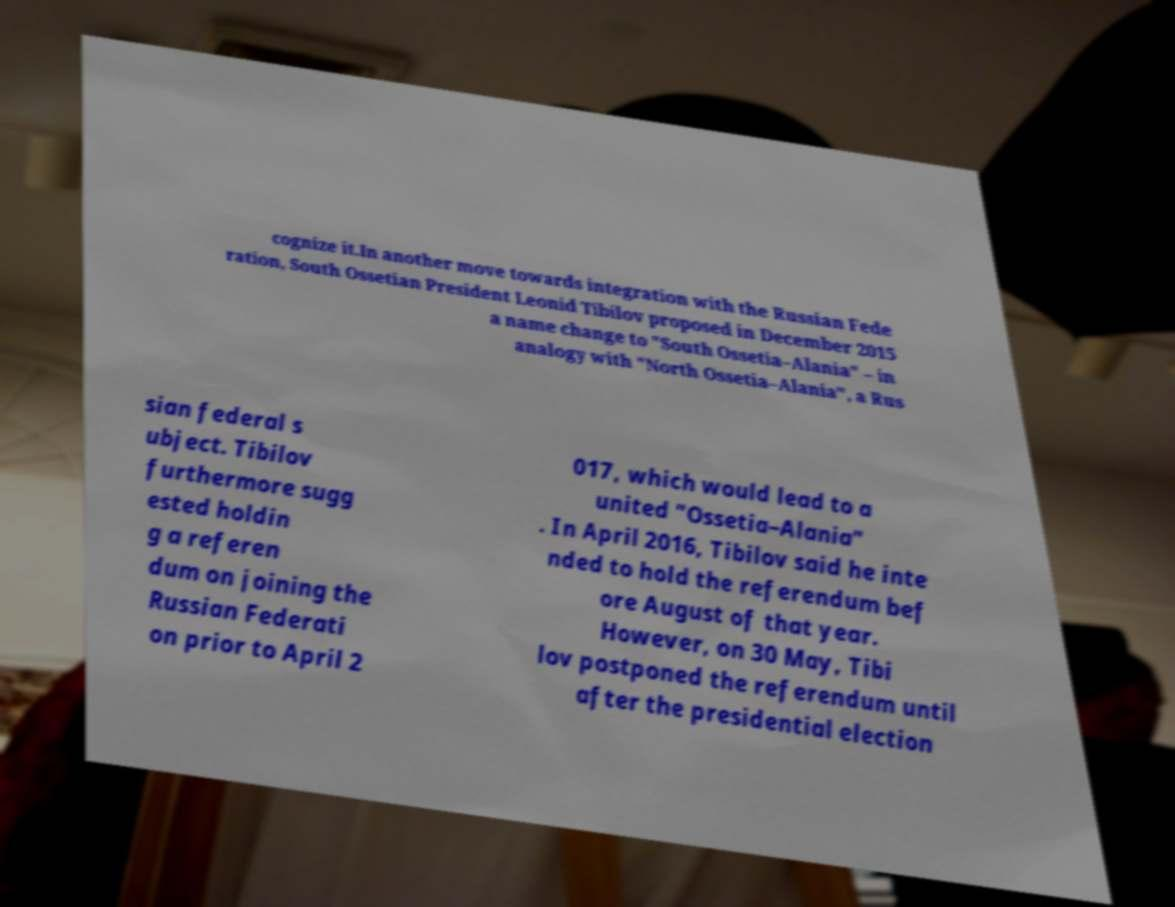I need the written content from this picture converted into text. Can you do that? cognize it.In another move towards integration with the Russian Fede ration, South Ossetian President Leonid Tibilov proposed in December 2015 a name change to "South Ossetia–Alania" – in analogy with "North Ossetia–Alania", a Rus sian federal s ubject. Tibilov furthermore sugg ested holdin g a referen dum on joining the Russian Federati on prior to April 2 017, which would lead to a united "Ossetia–Alania" . In April 2016, Tibilov said he inte nded to hold the referendum bef ore August of that year. However, on 30 May, Tibi lov postponed the referendum until after the presidential election 